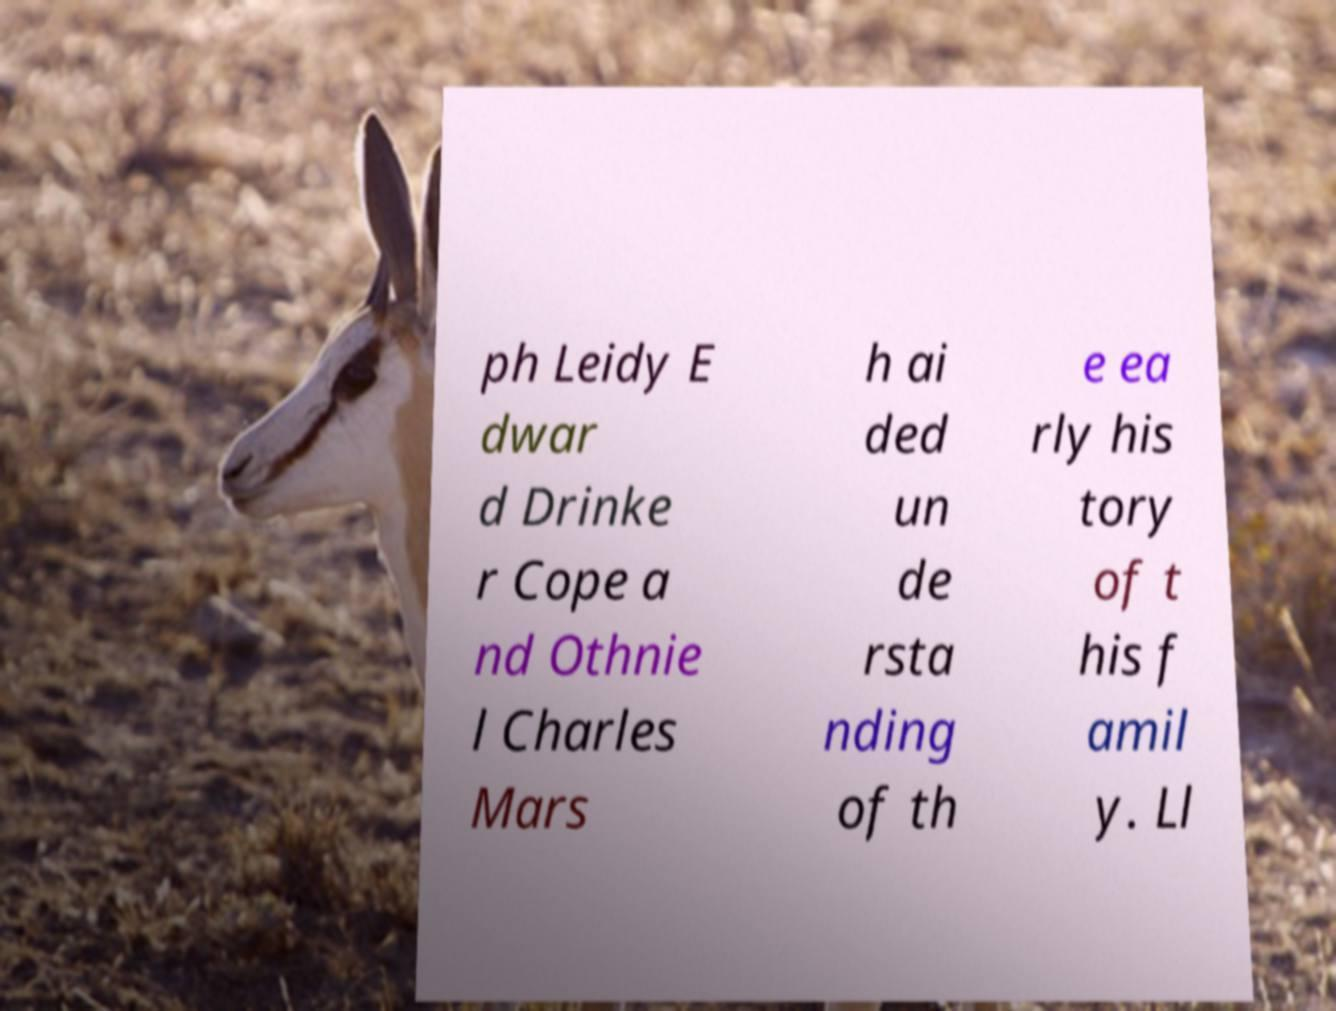Please identify and transcribe the text found in this image. ph Leidy E dwar d Drinke r Cope a nd Othnie l Charles Mars h ai ded un de rsta nding of th e ea rly his tory of t his f amil y. Ll 